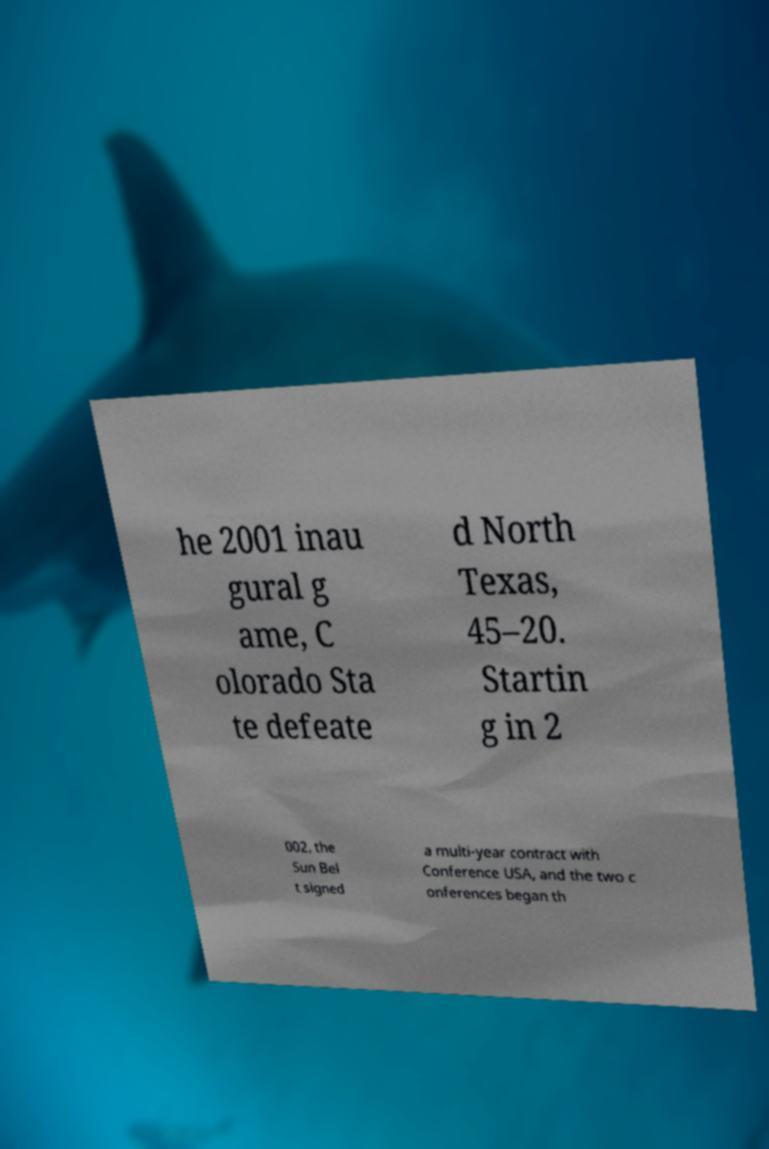Can you read and provide the text displayed in the image?This photo seems to have some interesting text. Can you extract and type it out for me? he 2001 inau gural g ame, C olorado Sta te defeate d North Texas, 45–20. Startin g in 2 002, the Sun Bel t signed a multi-year contract with Conference USA, and the two c onferences began th 